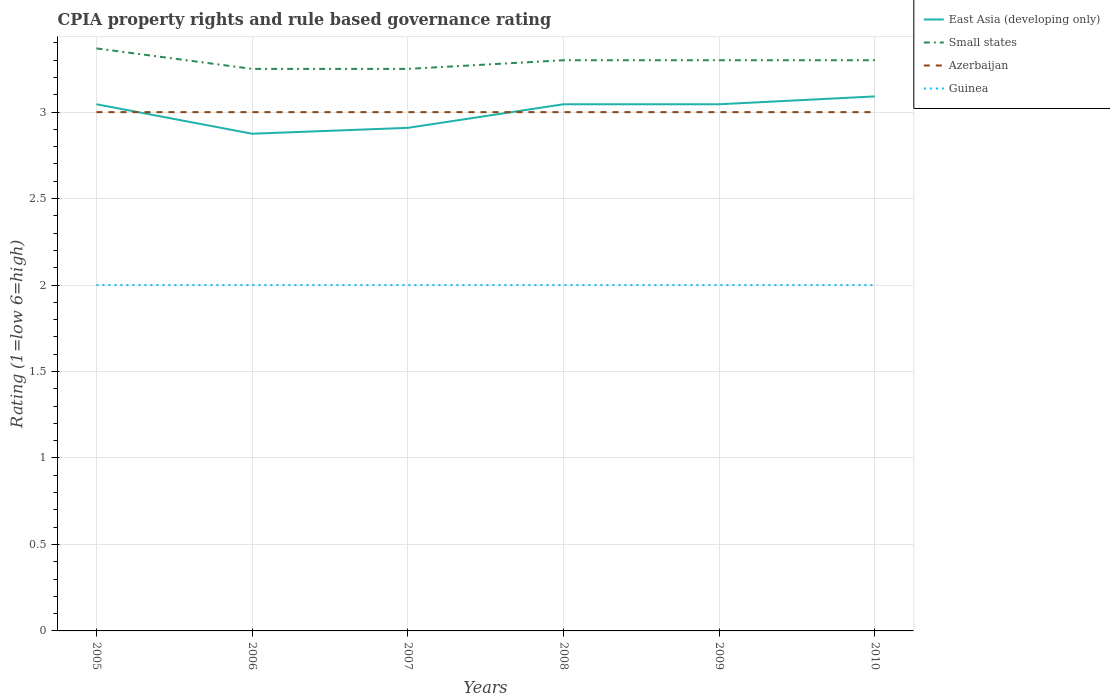How many different coloured lines are there?
Your answer should be compact. 4. Across all years, what is the maximum CPIA rating in East Asia (developing only)?
Offer a very short reply. 2.88. What is the total CPIA rating in Small states in the graph?
Provide a short and direct response. -0.05. What is the difference between the highest and the second highest CPIA rating in Azerbaijan?
Ensure brevity in your answer.  0. Does the graph contain grids?
Ensure brevity in your answer.  Yes. Where does the legend appear in the graph?
Your answer should be compact. Top right. How many legend labels are there?
Your answer should be very brief. 4. How are the legend labels stacked?
Your response must be concise. Vertical. What is the title of the graph?
Your response must be concise. CPIA property rights and rule based governance rating. Does "Guam" appear as one of the legend labels in the graph?
Give a very brief answer. No. What is the Rating (1=low 6=high) of East Asia (developing only) in 2005?
Keep it short and to the point. 3.05. What is the Rating (1=low 6=high) in Small states in 2005?
Provide a short and direct response. 3.37. What is the Rating (1=low 6=high) of Azerbaijan in 2005?
Give a very brief answer. 3. What is the Rating (1=low 6=high) of East Asia (developing only) in 2006?
Your response must be concise. 2.88. What is the Rating (1=low 6=high) in Small states in 2006?
Offer a terse response. 3.25. What is the Rating (1=low 6=high) of East Asia (developing only) in 2007?
Keep it short and to the point. 2.91. What is the Rating (1=low 6=high) of Small states in 2007?
Offer a terse response. 3.25. What is the Rating (1=low 6=high) in Guinea in 2007?
Your answer should be very brief. 2. What is the Rating (1=low 6=high) of East Asia (developing only) in 2008?
Provide a succinct answer. 3.05. What is the Rating (1=low 6=high) in Small states in 2008?
Ensure brevity in your answer.  3.3. What is the Rating (1=low 6=high) of Azerbaijan in 2008?
Keep it short and to the point. 3. What is the Rating (1=low 6=high) of Guinea in 2008?
Provide a succinct answer. 2. What is the Rating (1=low 6=high) in East Asia (developing only) in 2009?
Your response must be concise. 3.05. What is the Rating (1=low 6=high) in East Asia (developing only) in 2010?
Offer a terse response. 3.09. Across all years, what is the maximum Rating (1=low 6=high) of East Asia (developing only)?
Ensure brevity in your answer.  3.09. Across all years, what is the maximum Rating (1=low 6=high) in Small states?
Ensure brevity in your answer.  3.37. Across all years, what is the maximum Rating (1=low 6=high) in Azerbaijan?
Keep it short and to the point. 3. Across all years, what is the maximum Rating (1=low 6=high) of Guinea?
Provide a short and direct response. 2. Across all years, what is the minimum Rating (1=low 6=high) in East Asia (developing only)?
Offer a very short reply. 2.88. Across all years, what is the minimum Rating (1=low 6=high) in Small states?
Give a very brief answer. 3.25. What is the total Rating (1=low 6=high) of East Asia (developing only) in the graph?
Offer a terse response. 18.01. What is the total Rating (1=low 6=high) of Small states in the graph?
Your answer should be very brief. 19.77. What is the difference between the Rating (1=low 6=high) in East Asia (developing only) in 2005 and that in 2006?
Your response must be concise. 0.17. What is the difference between the Rating (1=low 6=high) in Small states in 2005 and that in 2006?
Your response must be concise. 0.12. What is the difference between the Rating (1=low 6=high) in Azerbaijan in 2005 and that in 2006?
Give a very brief answer. 0. What is the difference between the Rating (1=low 6=high) in Guinea in 2005 and that in 2006?
Your response must be concise. 0. What is the difference between the Rating (1=low 6=high) in East Asia (developing only) in 2005 and that in 2007?
Offer a terse response. 0.14. What is the difference between the Rating (1=low 6=high) in Small states in 2005 and that in 2007?
Offer a very short reply. 0.12. What is the difference between the Rating (1=low 6=high) in Guinea in 2005 and that in 2007?
Offer a terse response. 0. What is the difference between the Rating (1=low 6=high) in East Asia (developing only) in 2005 and that in 2008?
Ensure brevity in your answer.  0. What is the difference between the Rating (1=low 6=high) in Small states in 2005 and that in 2008?
Make the answer very short. 0.07. What is the difference between the Rating (1=low 6=high) in Azerbaijan in 2005 and that in 2008?
Your answer should be compact. 0. What is the difference between the Rating (1=low 6=high) in Guinea in 2005 and that in 2008?
Keep it short and to the point. 0. What is the difference between the Rating (1=low 6=high) in East Asia (developing only) in 2005 and that in 2009?
Offer a very short reply. 0. What is the difference between the Rating (1=low 6=high) in Small states in 2005 and that in 2009?
Your response must be concise. 0.07. What is the difference between the Rating (1=low 6=high) in Azerbaijan in 2005 and that in 2009?
Your answer should be very brief. 0. What is the difference between the Rating (1=low 6=high) in Guinea in 2005 and that in 2009?
Your answer should be very brief. 0. What is the difference between the Rating (1=low 6=high) in East Asia (developing only) in 2005 and that in 2010?
Your answer should be compact. -0.05. What is the difference between the Rating (1=low 6=high) in Small states in 2005 and that in 2010?
Make the answer very short. 0.07. What is the difference between the Rating (1=low 6=high) in East Asia (developing only) in 2006 and that in 2007?
Your answer should be compact. -0.03. What is the difference between the Rating (1=low 6=high) of Azerbaijan in 2006 and that in 2007?
Offer a very short reply. 0. What is the difference between the Rating (1=low 6=high) in East Asia (developing only) in 2006 and that in 2008?
Ensure brevity in your answer.  -0.17. What is the difference between the Rating (1=low 6=high) of Small states in 2006 and that in 2008?
Offer a very short reply. -0.05. What is the difference between the Rating (1=low 6=high) in Guinea in 2006 and that in 2008?
Ensure brevity in your answer.  0. What is the difference between the Rating (1=low 6=high) in East Asia (developing only) in 2006 and that in 2009?
Give a very brief answer. -0.17. What is the difference between the Rating (1=low 6=high) of Small states in 2006 and that in 2009?
Offer a very short reply. -0.05. What is the difference between the Rating (1=low 6=high) in Guinea in 2006 and that in 2009?
Ensure brevity in your answer.  0. What is the difference between the Rating (1=low 6=high) in East Asia (developing only) in 2006 and that in 2010?
Ensure brevity in your answer.  -0.22. What is the difference between the Rating (1=low 6=high) of Small states in 2006 and that in 2010?
Offer a very short reply. -0.05. What is the difference between the Rating (1=low 6=high) of East Asia (developing only) in 2007 and that in 2008?
Give a very brief answer. -0.14. What is the difference between the Rating (1=low 6=high) in Azerbaijan in 2007 and that in 2008?
Your response must be concise. 0. What is the difference between the Rating (1=low 6=high) of East Asia (developing only) in 2007 and that in 2009?
Keep it short and to the point. -0.14. What is the difference between the Rating (1=low 6=high) of Guinea in 2007 and that in 2009?
Provide a short and direct response. 0. What is the difference between the Rating (1=low 6=high) in East Asia (developing only) in 2007 and that in 2010?
Provide a short and direct response. -0.18. What is the difference between the Rating (1=low 6=high) in Guinea in 2007 and that in 2010?
Your response must be concise. 0. What is the difference between the Rating (1=low 6=high) of East Asia (developing only) in 2008 and that in 2009?
Provide a succinct answer. 0. What is the difference between the Rating (1=low 6=high) of Small states in 2008 and that in 2009?
Your answer should be compact. 0. What is the difference between the Rating (1=low 6=high) in Azerbaijan in 2008 and that in 2009?
Your response must be concise. 0. What is the difference between the Rating (1=low 6=high) of East Asia (developing only) in 2008 and that in 2010?
Make the answer very short. -0.05. What is the difference between the Rating (1=low 6=high) of Small states in 2008 and that in 2010?
Offer a terse response. 0. What is the difference between the Rating (1=low 6=high) in Guinea in 2008 and that in 2010?
Make the answer very short. 0. What is the difference between the Rating (1=low 6=high) of East Asia (developing only) in 2009 and that in 2010?
Keep it short and to the point. -0.05. What is the difference between the Rating (1=low 6=high) of Azerbaijan in 2009 and that in 2010?
Provide a succinct answer. 0. What is the difference between the Rating (1=low 6=high) in East Asia (developing only) in 2005 and the Rating (1=low 6=high) in Small states in 2006?
Offer a very short reply. -0.2. What is the difference between the Rating (1=low 6=high) in East Asia (developing only) in 2005 and the Rating (1=low 6=high) in Azerbaijan in 2006?
Provide a succinct answer. 0.05. What is the difference between the Rating (1=low 6=high) of East Asia (developing only) in 2005 and the Rating (1=low 6=high) of Guinea in 2006?
Make the answer very short. 1.05. What is the difference between the Rating (1=low 6=high) in Small states in 2005 and the Rating (1=low 6=high) in Azerbaijan in 2006?
Your answer should be compact. 0.37. What is the difference between the Rating (1=low 6=high) of Small states in 2005 and the Rating (1=low 6=high) of Guinea in 2006?
Offer a very short reply. 1.37. What is the difference between the Rating (1=low 6=high) in Azerbaijan in 2005 and the Rating (1=low 6=high) in Guinea in 2006?
Your answer should be compact. 1. What is the difference between the Rating (1=low 6=high) in East Asia (developing only) in 2005 and the Rating (1=low 6=high) in Small states in 2007?
Ensure brevity in your answer.  -0.2. What is the difference between the Rating (1=low 6=high) in East Asia (developing only) in 2005 and the Rating (1=low 6=high) in Azerbaijan in 2007?
Provide a succinct answer. 0.05. What is the difference between the Rating (1=low 6=high) of East Asia (developing only) in 2005 and the Rating (1=low 6=high) of Guinea in 2007?
Keep it short and to the point. 1.05. What is the difference between the Rating (1=low 6=high) of Small states in 2005 and the Rating (1=low 6=high) of Azerbaijan in 2007?
Your response must be concise. 0.37. What is the difference between the Rating (1=low 6=high) in Small states in 2005 and the Rating (1=low 6=high) in Guinea in 2007?
Your answer should be compact. 1.37. What is the difference between the Rating (1=low 6=high) in Azerbaijan in 2005 and the Rating (1=low 6=high) in Guinea in 2007?
Offer a very short reply. 1. What is the difference between the Rating (1=low 6=high) in East Asia (developing only) in 2005 and the Rating (1=low 6=high) in Small states in 2008?
Give a very brief answer. -0.25. What is the difference between the Rating (1=low 6=high) in East Asia (developing only) in 2005 and the Rating (1=low 6=high) in Azerbaijan in 2008?
Your answer should be very brief. 0.05. What is the difference between the Rating (1=low 6=high) of East Asia (developing only) in 2005 and the Rating (1=low 6=high) of Guinea in 2008?
Provide a short and direct response. 1.05. What is the difference between the Rating (1=low 6=high) in Small states in 2005 and the Rating (1=low 6=high) in Azerbaijan in 2008?
Your response must be concise. 0.37. What is the difference between the Rating (1=low 6=high) of Small states in 2005 and the Rating (1=low 6=high) of Guinea in 2008?
Provide a short and direct response. 1.37. What is the difference between the Rating (1=low 6=high) of East Asia (developing only) in 2005 and the Rating (1=low 6=high) of Small states in 2009?
Ensure brevity in your answer.  -0.25. What is the difference between the Rating (1=low 6=high) of East Asia (developing only) in 2005 and the Rating (1=low 6=high) of Azerbaijan in 2009?
Provide a short and direct response. 0.05. What is the difference between the Rating (1=low 6=high) in East Asia (developing only) in 2005 and the Rating (1=low 6=high) in Guinea in 2009?
Make the answer very short. 1.05. What is the difference between the Rating (1=low 6=high) in Small states in 2005 and the Rating (1=low 6=high) in Azerbaijan in 2009?
Give a very brief answer. 0.37. What is the difference between the Rating (1=low 6=high) in Small states in 2005 and the Rating (1=low 6=high) in Guinea in 2009?
Make the answer very short. 1.37. What is the difference between the Rating (1=low 6=high) of East Asia (developing only) in 2005 and the Rating (1=low 6=high) of Small states in 2010?
Ensure brevity in your answer.  -0.25. What is the difference between the Rating (1=low 6=high) of East Asia (developing only) in 2005 and the Rating (1=low 6=high) of Azerbaijan in 2010?
Your answer should be very brief. 0.05. What is the difference between the Rating (1=low 6=high) in East Asia (developing only) in 2005 and the Rating (1=low 6=high) in Guinea in 2010?
Your answer should be very brief. 1.05. What is the difference between the Rating (1=low 6=high) in Small states in 2005 and the Rating (1=low 6=high) in Azerbaijan in 2010?
Give a very brief answer. 0.37. What is the difference between the Rating (1=low 6=high) in Small states in 2005 and the Rating (1=low 6=high) in Guinea in 2010?
Provide a short and direct response. 1.37. What is the difference between the Rating (1=low 6=high) of East Asia (developing only) in 2006 and the Rating (1=low 6=high) of Small states in 2007?
Give a very brief answer. -0.38. What is the difference between the Rating (1=low 6=high) in East Asia (developing only) in 2006 and the Rating (1=low 6=high) in Azerbaijan in 2007?
Give a very brief answer. -0.12. What is the difference between the Rating (1=low 6=high) in Small states in 2006 and the Rating (1=low 6=high) in Guinea in 2007?
Keep it short and to the point. 1.25. What is the difference between the Rating (1=low 6=high) in East Asia (developing only) in 2006 and the Rating (1=low 6=high) in Small states in 2008?
Ensure brevity in your answer.  -0.42. What is the difference between the Rating (1=low 6=high) in East Asia (developing only) in 2006 and the Rating (1=low 6=high) in Azerbaijan in 2008?
Offer a terse response. -0.12. What is the difference between the Rating (1=low 6=high) of East Asia (developing only) in 2006 and the Rating (1=low 6=high) of Small states in 2009?
Ensure brevity in your answer.  -0.42. What is the difference between the Rating (1=low 6=high) of East Asia (developing only) in 2006 and the Rating (1=low 6=high) of Azerbaijan in 2009?
Offer a very short reply. -0.12. What is the difference between the Rating (1=low 6=high) in Azerbaijan in 2006 and the Rating (1=low 6=high) in Guinea in 2009?
Ensure brevity in your answer.  1. What is the difference between the Rating (1=low 6=high) in East Asia (developing only) in 2006 and the Rating (1=low 6=high) in Small states in 2010?
Provide a succinct answer. -0.42. What is the difference between the Rating (1=low 6=high) of East Asia (developing only) in 2006 and the Rating (1=low 6=high) of Azerbaijan in 2010?
Provide a short and direct response. -0.12. What is the difference between the Rating (1=low 6=high) of Small states in 2006 and the Rating (1=low 6=high) of Azerbaijan in 2010?
Keep it short and to the point. 0.25. What is the difference between the Rating (1=low 6=high) of East Asia (developing only) in 2007 and the Rating (1=low 6=high) of Small states in 2008?
Offer a terse response. -0.39. What is the difference between the Rating (1=low 6=high) of East Asia (developing only) in 2007 and the Rating (1=low 6=high) of Azerbaijan in 2008?
Offer a terse response. -0.09. What is the difference between the Rating (1=low 6=high) of Small states in 2007 and the Rating (1=low 6=high) of Azerbaijan in 2008?
Keep it short and to the point. 0.25. What is the difference between the Rating (1=low 6=high) of Small states in 2007 and the Rating (1=low 6=high) of Guinea in 2008?
Offer a terse response. 1.25. What is the difference between the Rating (1=low 6=high) in East Asia (developing only) in 2007 and the Rating (1=low 6=high) in Small states in 2009?
Offer a terse response. -0.39. What is the difference between the Rating (1=low 6=high) in East Asia (developing only) in 2007 and the Rating (1=low 6=high) in Azerbaijan in 2009?
Provide a succinct answer. -0.09. What is the difference between the Rating (1=low 6=high) in East Asia (developing only) in 2007 and the Rating (1=low 6=high) in Small states in 2010?
Offer a terse response. -0.39. What is the difference between the Rating (1=low 6=high) in East Asia (developing only) in 2007 and the Rating (1=low 6=high) in Azerbaijan in 2010?
Your answer should be compact. -0.09. What is the difference between the Rating (1=low 6=high) of East Asia (developing only) in 2007 and the Rating (1=low 6=high) of Guinea in 2010?
Ensure brevity in your answer.  0.91. What is the difference between the Rating (1=low 6=high) of East Asia (developing only) in 2008 and the Rating (1=low 6=high) of Small states in 2009?
Give a very brief answer. -0.25. What is the difference between the Rating (1=low 6=high) of East Asia (developing only) in 2008 and the Rating (1=low 6=high) of Azerbaijan in 2009?
Ensure brevity in your answer.  0.05. What is the difference between the Rating (1=low 6=high) of East Asia (developing only) in 2008 and the Rating (1=low 6=high) of Guinea in 2009?
Provide a short and direct response. 1.05. What is the difference between the Rating (1=low 6=high) of Small states in 2008 and the Rating (1=low 6=high) of Azerbaijan in 2009?
Make the answer very short. 0.3. What is the difference between the Rating (1=low 6=high) of Azerbaijan in 2008 and the Rating (1=low 6=high) of Guinea in 2009?
Your answer should be very brief. 1. What is the difference between the Rating (1=low 6=high) in East Asia (developing only) in 2008 and the Rating (1=low 6=high) in Small states in 2010?
Give a very brief answer. -0.25. What is the difference between the Rating (1=low 6=high) in East Asia (developing only) in 2008 and the Rating (1=low 6=high) in Azerbaijan in 2010?
Your response must be concise. 0.05. What is the difference between the Rating (1=low 6=high) in East Asia (developing only) in 2008 and the Rating (1=low 6=high) in Guinea in 2010?
Offer a terse response. 1.05. What is the difference between the Rating (1=low 6=high) in Small states in 2008 and the Rating (1=low 6=high) in Azerbaijan in 2010?
Offer a very short reply. 0.3. What is the difference between the Rating (1=low 6=high) in Small states in 2008 and the Rating (1=low 6=high) in Guinea in 2010?
Your answer should be very brief. 1.3. What is the difference between the Rating (1=low 6=high) in Azerbaijan in 2008 and the Rating (1=low 6=high) in Guinea in 2010?
Make the answer very short. 1. What is the difference between the Rating (1=low 6=high) in East Asia (developing only) in 2009 and the Rating (1=low 6=high) in Small states in 2010?
Provide a succinct answer. -0.25. What is the difference between the Rating (1=low 6=high) in East Asia (developing only) in 2009 and the Rating (1=low 6=high) in Azerbaijan in 2010?
Give a very brief answer. 0.05. What is the difference between the Rating (1=low 6=high) of East Asia (developing only) in 2009 and the Rating (1=low 6=high) of Guinea in 2010?
Keep it short and to the point. 1.05. What is the difference between the Rating (1=low 6=high) of Small states in 2009 and the Rating (1=low 6=high) of Guinea in 2010?
Keep it short and to the point. 1.3. What is the average Rating (1=low 6=high) of East Asia (developing only) per year?
Provide a succinct answer. 3. What is the average Rating (1=low 6=high) of Small states per year?
Keep it short and to the point. 3.29. What is the average Rating (1=low 6=high) of Azerbaijan per year?
Provide a short and direct response. 3. What is the average Rating (1=low 6=high) in Guinea per year?
Give a very brief answer. 2. In the year 2005, what is the difference between the Rating (1=low 6=high) in East Asia (developing only) and Rating (1=low 6=high) in Small states?
Your answer should be compact. -0.32. In the year 2005, what is the difference between the Rating (1=low 6=high) in East Asia (developing only) and Rating (1=low 6=high) in Azerbaijan?
Offer a very short reply. 0.05. In the year 2005, what is the difference between the Rating (1=low 6=high) of East Asia (developing only) and Rating (1=low 6=high) of Guinea?
Keep it short and to the point. 1.05. In the year 2005, what is the difference between the Rating (1=low 6=high) of Small states and Rating (1=low 6=high) of Azerbaijan?
Provide a short and direct response. 0.37. In the year 2005, what is the difference between the Rating (1=low 6=high) in Small states and Rating (1=low 6=high) in Guinea?
Ensure brevity in your answer.  1.37. In the year 2005, what is the difference between the Rating (1=low 6=high) in Azerbaijan and Rating (1=low 6=high) in Guinea?
Offer a very short reply. 1. In the year 2006, what is the difference between the Rating (1=low 6=high) in East Asia (developing only) and Rating (1=low 6=high) in Small states?
Offer a very short reply. -0.38. In the year 2006, what is the difference between the Rating (1=low 6=high) in East Asia (developing only) and Rating (1=low 6=high) in Azerbaijan?
Your answer should be very brief. -0.12. In the year 2006, what is the difference between the Rating (1=low 6=high) in East Asia (developing only) and Rating (1=low 6=high) in Guinea?
Offer a terse response. 0.88. In the year 2006, what is the difference between the Rating (1=low 6=high) of Azerbaijan and Rating (1=low 6=high) of Guinea?
Offer a terse response. 1. In the year 2007, what is the difference between the Rating (1=low 6=high) of East Asia (developing only) and Rating (1=low 6=high) of Small states?
Your answer should be very brief. -0.34. In the year 2007, what is the difference between the Rating (1=low 6=high) in East Asia (developing only) and Rating (1=low 6=high) in Azerbaijan?
Your answer should be compact. -0.09. In the year 2007, what is the difference between the Rating (1=low 6=high) in Small states and Rating (1=low 6=high) in Azerbaijan?
Offer a very short reply. 0.25. In the year 2007, what is the difference between the Rating (1=low 6=high) of Azerbaijan and Rating (1=low 6=high) of Guinea?
Keep it short and to the point. 1. In the year 2008, what is the difference between the Rating (1=low 6=high) of East Asia (developing only) and Rating (1=low 6=high) of Small states?
Offer a terse response. -0.25. In the year 2008, what is the difference between the Rating (1=low 6=high) in East Asia (developing only) and Rating (1=low 6=high) in Azerbaijan?
Keep it short and to the point. 0.05. In the year 2008, what is the difference between the Rating (1=low 6=high) of East Asia (developing only) and Rating (1=low 6=high) of Guinea?
Your answer should be compact. 1.05. In the year 2008, what is the difference between the Rating (1=low 6=high) of Small states and Rating (1=low 6=high) of Guinea?
Provide a short and direct response. 1.3. In the year 2009, what is the difference between the Rating (1=low 6=high) of East Asia (developing only) and Rating (1=low 6=high) of Small states?
Keep it short and to the point. -0.25. In the year 2009, what is the difference between the Rating (1=low 6=high) of East Asia (developing only) and Rating (1=low 6=high) of Azerbaijan?
Give a very brief answer. 0.05. In the year 2009, what is the difference between the Rating (1=low 6=high) in East Asia (developing only) and Rating (1=low 6=high) in Guinea?
Make the answer very short. 1.05. In the year 2009, what is the difference between the Rating (1=low 6=high) in Small states and Rating (1=low 6=high) in Guinea?
Your response must be concise. 1.3. In the year 2009, what is the difference between the Rating (1=low 6=high) in Azerbaijan and Rating (1=low 6=high) in Guinea?
Give a very brief answer. 1. In the year 2010, what is the difference between the Rating (1=low 6=high) of East Asia (developing only) and Rating (1=low 6=high) of Small states?
Your response must be concise. -0.21. In the year 2010, what is the difference between the Rating (1=low 6=high) of East Asia (developing only) and Rating (1=low 6=high) of Azerbaijan?
Provide a short and direct response. 0.09. In the year 2010, what is the difference between the Rating (1=low 6=high) of Small states and Rating (1=low 6=high) of Guinea?
Make the answer very short. 1.3. In the year 2010, what is the difference between the Rating (1=low 6=high) in Azerbaijan and Rating (1=low 6=high) in Guinea?
Give a very brief answer. 1. What is the ratio of the Rating (1=low 6=high) in East Asia (developing only) in 2005 to that in 2006?
Your answer should be very brief. 1.06. What is the ratio of the Rating (1=low 6=high) of Small states in 2005 to that in 2006?
Offer a terse response. 1.04. What is the ratio of the Rating (1=low 6=high) in Azerbaijan in 2005 to that in 2006?
Make the answer very short. 1. What is the ratio of the Rating (1=low 6=high) in East Asia (developing only) in 2005 to that in 2007?
Make the answer very short. 1.05. What is the ratio of the Rating (1=low 6=high) of Small states in 2005 to that in 2007?
Provide a succinct answer. 1.04. What is the ratio of the Rating (1=low 6=high) in Azerbaijan in 2005 to that in 2007?
Offer a terse response. 1. What is the ratio of the Rating (1=low 6=high) in Guinea in 2005 to that in 2007?
Provide a short and direct response. 1. What is the ratio of the Rating (1=low 6=high) of East Asia (developing only) in 2005 to that in 2008?
Provide a succinct answer. 1. What is the ratio of the Rating (1=low 6=high) in Small states in 2005 to that in 2008?
Offer a very short reply. 1.02. What is the ratio of the Rating (1=low 6=high) in Azerbaijan in 2005 to that in 2008?
Provide a short and direct response. 1. What is the ratio of the Rating (1=low 6=high) of Guinea in 2005 to that in 2008?
Make the answer very short. 1. What is the ratio of the Rating (1=low 6=high) of Small states in 2005 to that in 2009?
Your answer should be very brief. 1.02. What is the ratio of the Rating (1=low 6=high) in East Asia (developing only) in 2005 to that in 2010?
Keep it short and to the point. 0.99. What is the ratio of the Rating (1=low 6=high) of Small states in 2005 to that in 2010?
Provide a short and direct response. 1.02. What is the ratio of the Rating (1=low 6=high) in Azerbaijan in 2005 to that in 2010?
Ensure brevity in your answer.  1. What is the ratio of the Rating (1=low 6=high) of Guinea in 2005 to that in 2010?
Offer a very short reply. 1. What is the ratio of the Rating (1=low 6=high) in East Asia (developing only) in 2006 to that in 2007?
Ensure brevity in your answer.  0.99. What is the ratio of the Rating (1=low 6=high) of Small states in 2006 to that in 2007?
Keep it short and to the point. 1. What is the ratio of the Rating (1=low 6=high) in East Asia (developing only) in 2006 to that in 2008?
Ensure brevity in your answer.  0.94. What is the ratio of the Rating (1=low 6=high) in Small states in 2006 to that in 2008?
Your response must be concise. 0.98. What is the ratio of the Rating (1=low 6=high) of Azerbaijan in 2006 to that in 2008?
Your answer should be very brief. 1. What is the ratio of the Rating (1=low 6=high) of East Asia (developing only) in 2006 to that in 2009?
Provide a succinct answer. 0.94. What is the ratio of the Rating (1=low 6=high) of Small states in 2006 to that in 2009?
Provide a succinct answer. 0.98. What is the ratio of the Rating (1=low 6=high) in Guinea in 2006 to that in 2009?
Offer a terse response. 1. What is the ratio of the Rating (1=low 6=high) in East Asia (developing only) in 2006 to that in 2010?
Give a very brief answer. 0.93. What is the ratio of the Rating (1=low 6=high) in Small states in 2006 to that in 2010?
Your answer should be compact. 0.98. What is the ratio of the Rating (1=low 6=high) of Azerbaijan in 2006 to that in 2010?
Your response must be concise. 1. What is the ratio of the Rating (1=low 6=high) in East Asia (developing only) in 2007 to that in 2008?
Offer a terse response. 0.96. What is the ratio of the Rating (1=low 6=high) of East Asia (developing only) in 2007 to that in 2009?
Make the answer very short. 0.96. What is the ratio of the Rating (1=low 6=high) of Small states in 2007 to that in 2009?
Ensure brevity in your answer.  0.98. What is the ratio of the Rating (1=low 6=high) in Azerbaijan in 2007 to that in 2009?
Your answer should be very brief. 1. What is the ratio of the Rating (1=low 6=high) of Small states in 2007 to that in 2010?
Provide a short and direct response. 0.98. What is the ratio of the Rating (1=low 6=high) in East Asia (developing only) in 2008 to that in 2009?
Your answer should be very brief. 1. What is the ratio of the Rating (1=low 6=high) in Azerbaijan in 2008 to that in 2009?
Give a very brief answer. 1. What is the ratio of the Rating (1=low 6=high) in East Asia (developing only) in 2008 to that in 2010?
Your answer should be very brief. 0.99. What is the ratio of the Rating (1=low 6=high) of Azerbaijan in 2008 to that in 2010?
Give a very brief answer. 1. What is the ratio of the Rating (1=low 6=high) of Guinea in 2008 to that in 2010?
Offer a terse response. 1. What is the difference between the highest and the second highest Rating (1=low 6=high) of East Asia (developing only)?
Provide a succinct answer. 0.05. What is the difference between the highest and the second highest Rating (1=low 6=high) of Small states?
Your answer should be very brief. 0.07. What is the difference between the highest and the second highest Rating (1=low 6=high) of Guinea?
Your answer should be very brief. 0. What is the difference between the highest and the lowest Rating (1=low 6=high) of East Asia (developing only)?
Ensure brevity in your answer.  0.22. What is the difference between the highest and the lowest Rating (1=low 6=high) in Small states?
Your answer should be compact. 0.12. 